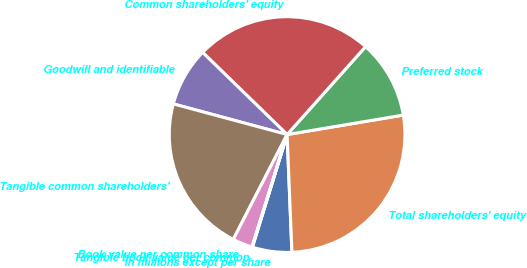Convert chart. <chart><loc_0><loc_0><loc_500><loc_500><pie_chart><fcel>in millions except per share<fcel>Total shareholders' equity<fcel>Preferred stock<fcel>Common shareholders' equity<fcel>Goodwill and identifiable<fcel>Tangible common shareholders'<fcel>Book value per common share<fcel>Tangible book value per common<nl><fcel>5.41%<fcel>26.99%<fcel>10.76%<fcel>24.32%<fcel>8.09%<fcel>21.64%<fcel>2.73%<fcel>0.06%<nl></chart> 